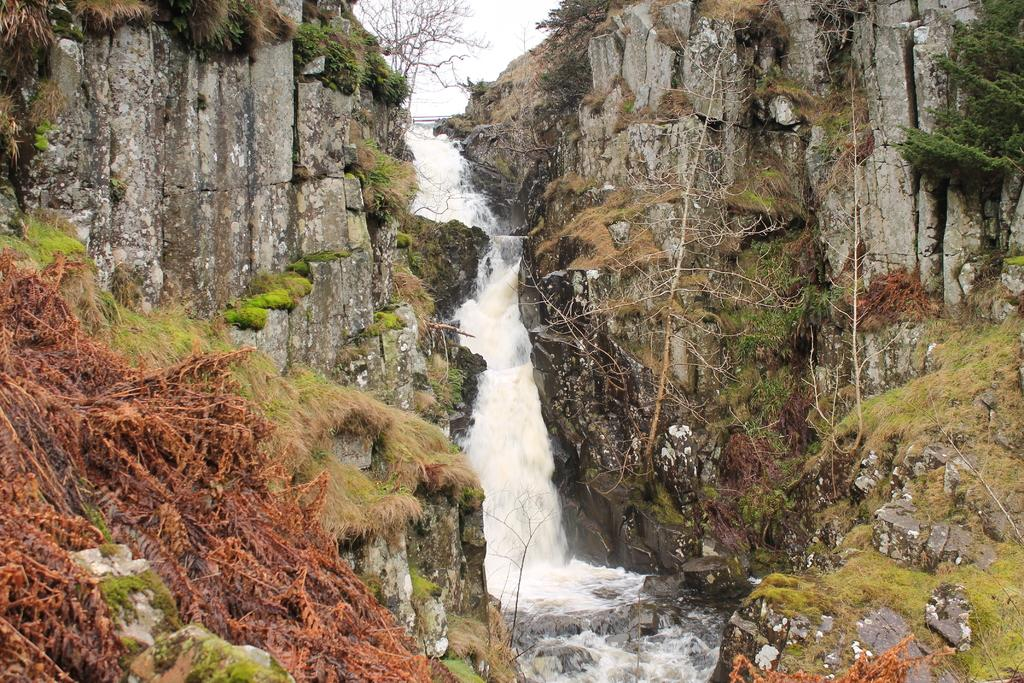What natural feature is the main subject of the image? There is a waterfall in the image. What type of vegetation can be seen on the right side of the image? There are trees on the right side of the image. What is the weight of the bird that is crying in the image? There is no bird present in the image, and therefore no weight or crying can be observed. 